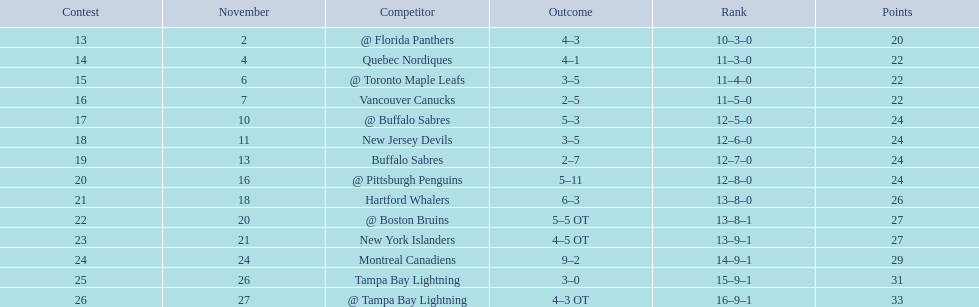What were the scores of the 1993-94 philadelphia flyers season? 4–3, 4–1, 3–5, 2–5, 5–3, 3–5, 2–7, 5–11, 6–3, 5–5 OT, 4–5 OT, 9–2, 3–0, 4–3 OT. Could you parse the entire table? {'header': ['Contest', 'November', 'Competitor', 'Outcome', 'Rank', 'Points'], 'rows': [['13', '2', '@ Florida Panthers', '4–3', '10–3–0', '20'], ['14', '4', 'Quebec Nordiques', '4–1', '11–3–0', '22'], ['15', '6', '@ Toronto Maple Leafs', '3–5', '11–4–0', '22'], ['16', '7', 'Vancouver Canucks', '2–5', '11–5–0', '22'], ['17', '10', '@ Buffalo Sabres', '5–3', '12–5–0', '24'], ['18', '11', 'New Jersey Devils', '3–5', '12–6–0', '24'], ['19', '13', 'Buffalo Sabres', '2–7', '12–7–0', '24'], ['20', '16', '@ Pittsburgh Penguins', '5–11', '12–8–0', '24'], ['21', '18', 'Hartford Whalers', '6–3', '13–8–0', '26'], ['22', '20', '@ Boston Bruins', '5–5 OT', '13–8–1', '27'], ['23', '21', 'New York Islanders', '4–5 OT', '13–9–1', '27'], ['24', '24', 'Montreal Canadiens', '9–2', '14–9–1', '29'], ['25', '26', 'Tampa Bay Lightning', '3–0', '15–9–1', '31'], ['26', '27', '@ Tampa Bay Lightning', '4–3 OT', '16–9–1', '33']]} Which of these teams had the score 4-5 ot? New York Islanders. 